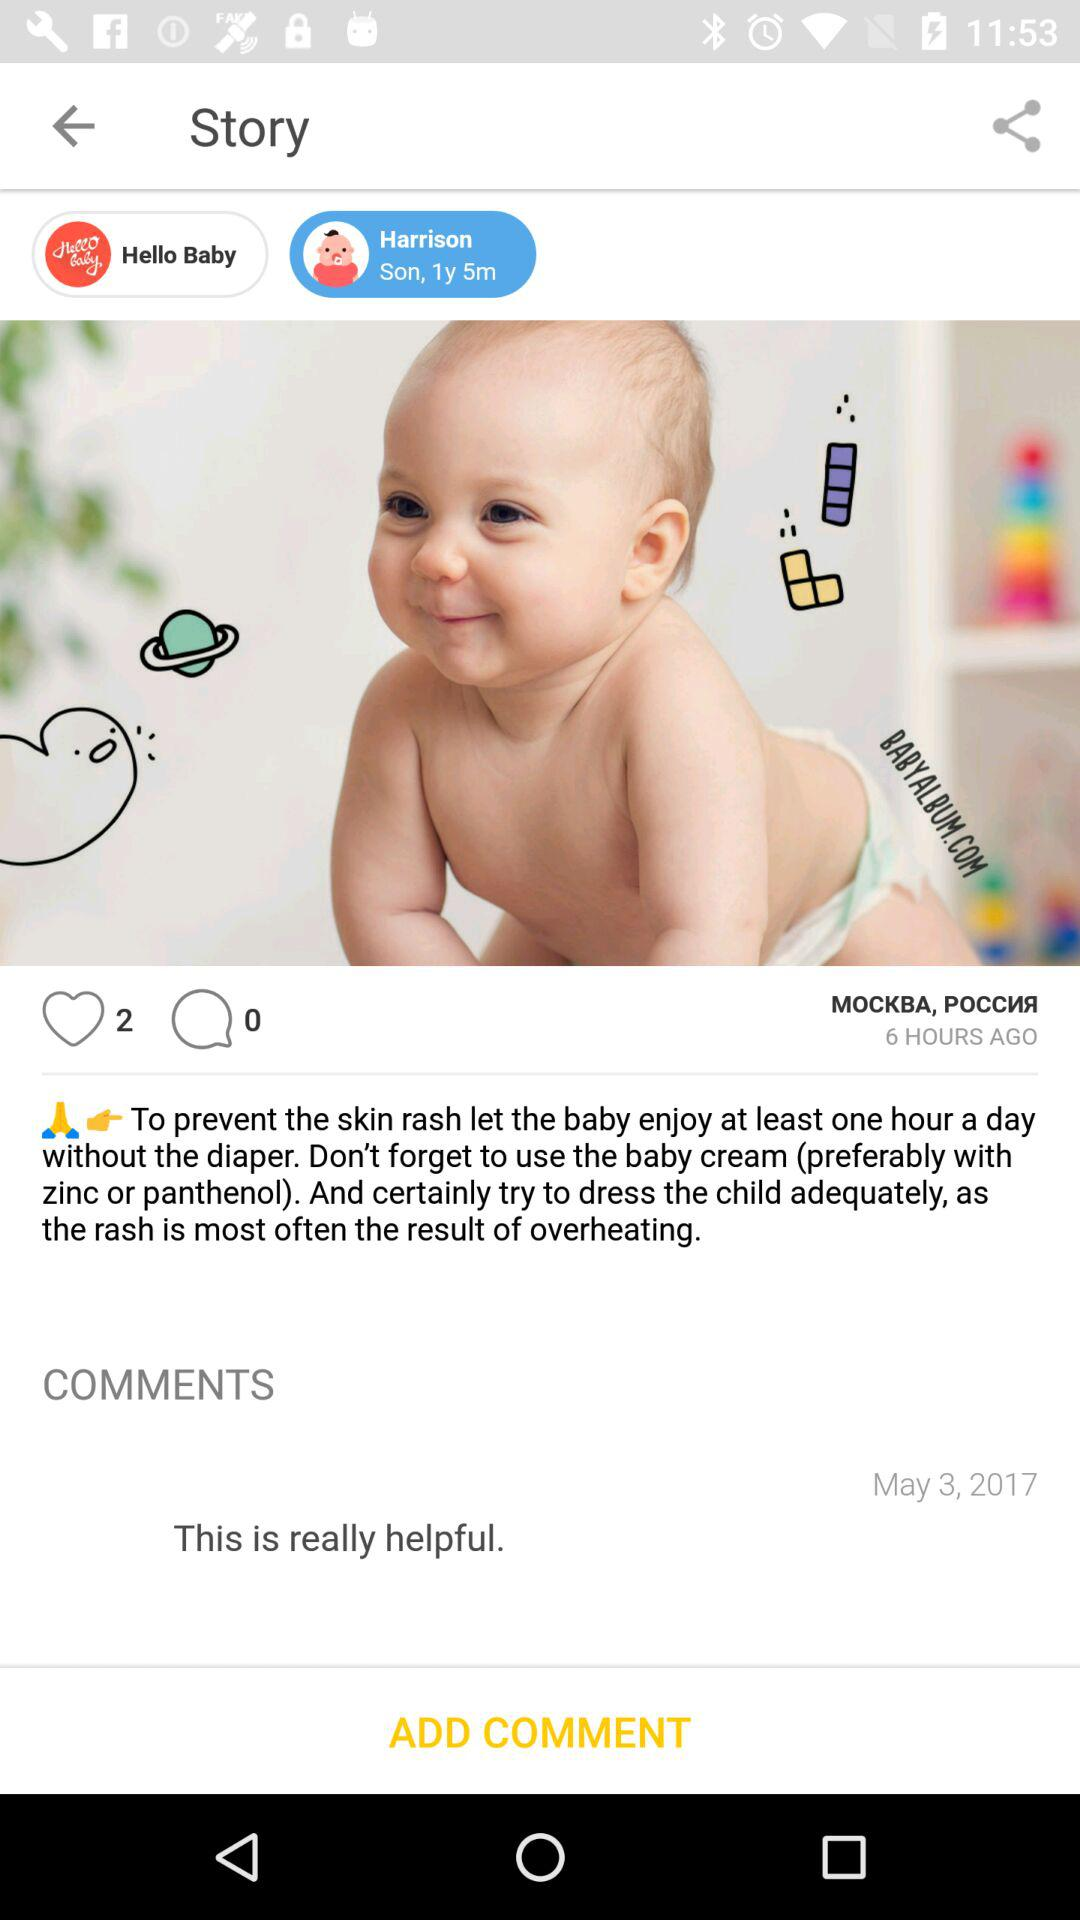What's the age of the baby? The age of the baby is 1 year 5 months. 